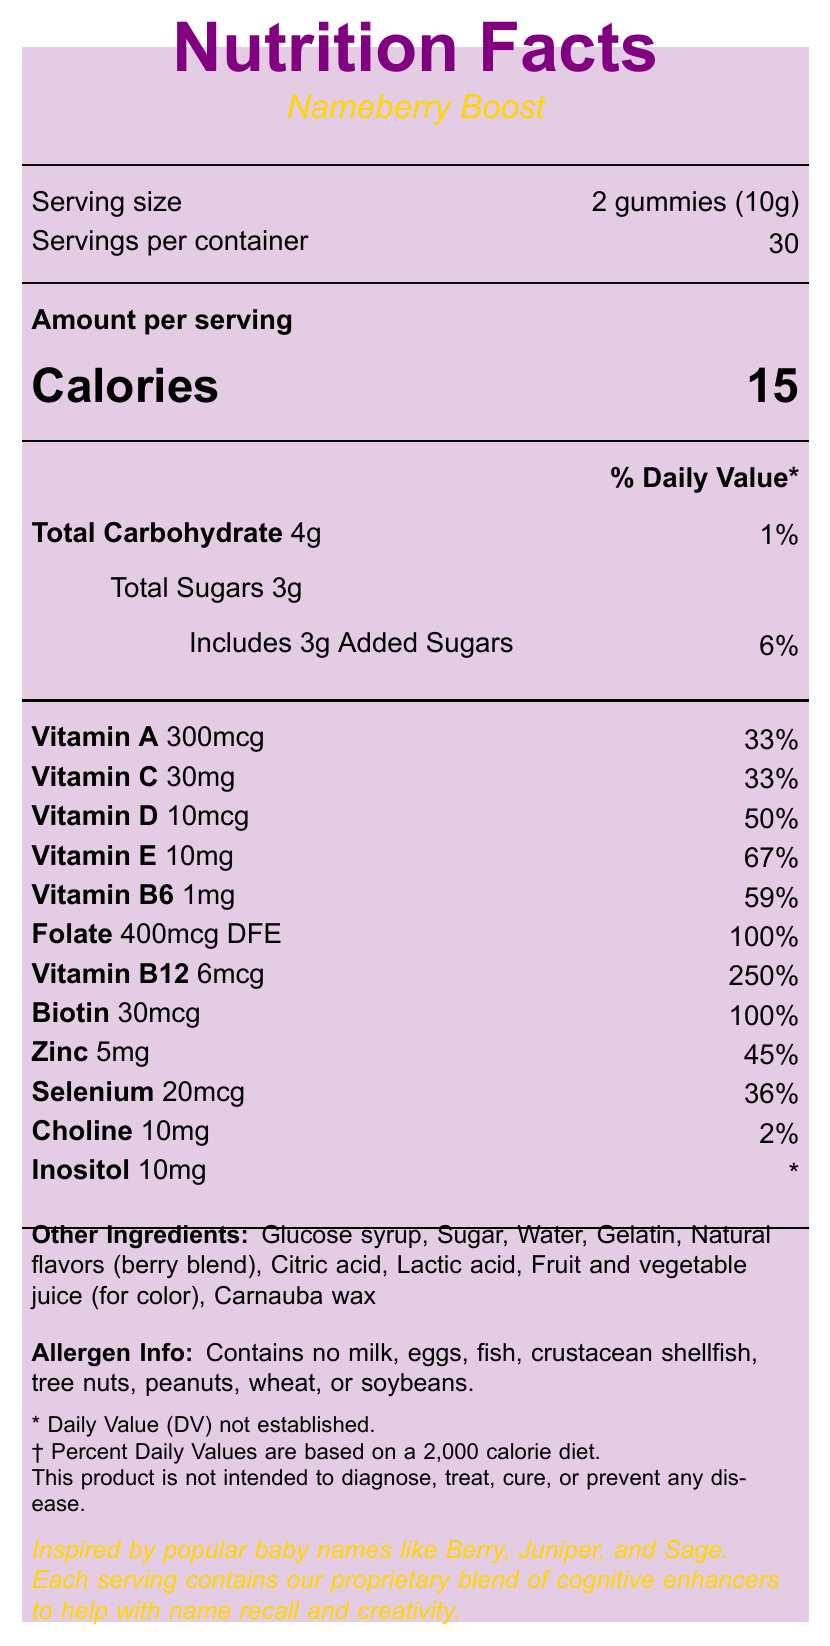what is the serving size for Nameberry Boost? The serving size is mentioned as "2 gummies (10g)" in the document under the serving information section.
Answer: 2 gummies (10g) how many servings are there in one container? The document mentions "Servings per container" as 30.
Answer: 30 what is the calorie content per serving? "Calories" per serving is listed as 15 in the document.
Answer: 15 calories what is the percentage of daily value for vitamin B12 per serving? The document lists the daily value percentage for vitamin B12 as 250%.
Answer: 250% what is the inspiration flavor of nameberry boost? This is stated in the document under the "nameberrySpecific" section.
Answer: Inspired by popular baby names like Berry, Juniper, and Sage how much added sugar is in each serving? The document under the "Total Sugars" section mentions that it includes 3g of added sugars.
Answer: 3g what minerals are included in nameberry boost? The minerals mentioned in the document are Zinc (5mg) and Selenium (20mcg).
Answer: Zinc, Selenium which nutrient has the highest percent daily value? 
A. Vitamin A 
B. Vitamin D 
C. Vitamin B6 
D. Vitamin B12 The document lists Vitamin B12 with a daily value of 250%, which is the highest among the listed nutrients.
Answer: D how many calories would be consumed by taking 3 servings? 
A. 15 calories 
B. 30 calories 
C. 45 calories 
D. 60 calories Each serving contains 15 calories, so 3 servings would be 15 calories x 3 = 45 calories.
Answer: C is the inositol daily value established? The document indicates that the daily value for Inositol is marked with an asterisk, noting "* Daily Value (DV) not established."
Answer: No describe the main idea of the document The document's main idea is to present the nutritional information, ingredients, and specific details about the Nameberry Boost vitamin supplement.
Answer: The document provides the Nutrition Facts for "Nameberry Boost", a flavored vitamin supplement. It lists the serving size, number of servings per container, calorie content, and detailed information about various vitamins, minerals, and other ingredients. Additionally, it includes allergen information, disclaimers, storage instructions, manufacturer details, and nameberry-specific inspiration. what percentage of daily value does Total Carbohydrate contribute? The document mentions "Total Carbohydrate 4g" which contributes to 1% of the daily value.
Answer: 1% does Nameberry Boost contain any milk or eggs? The allergen info in the document states that it contains no milk, eggs, fish, crustacean shellfish, tree nuts, peanuts, wheat, or soybeans.
Answer: No where is Nameberry Boost manufactured? The manufacturer information in the document states: "Manufactured for Nameberry Nutrition, Los Angeles, CA 90001".
Answer: Los Angeles, CA 90001 what is the daily value percentage of Folate in Nameberry Boost? The document lists the daily value percentage for Folate as 100%.
Answer: 100% does the product claim to diagnose, treat, cure, or prevent any disease? The disclaimer section specifically states, "This product is not intended to diagnose, treat, cure, or prevent any disease."
Answer: No what is the total carbohydrate amount per serving in grams? The document mentions the total carbohydrate amount per serving as 4g.
Answer: 4g what is the total number of grams of sugar per serving, including added sugars? The document mentions Total Sugars as 3g and includes 3g Added Sugars as a part of it.
Answer: 3g what are the natural flavor components listed in the ingredients? The document mentions "Natural flavors (berry blend)" in the ingredients section.
Answer: Berry blend how much biotin does each serving of Nameberry Boost provide? The document lists Biotin as providing 30mcg per serving.
Answer: 30mcg what kind of juice is used for color in the ingredients? The document mentions "Fruit and vegetable juice (for color)" in the list of other ingredients.
Answer: Fruit and vegetable juice who is the chief nutritionist at Nameberry Nutrition? The document does not provide any information about the chief nutritionist at Nameberry Nutrition.
Answer: Cannot be determined 